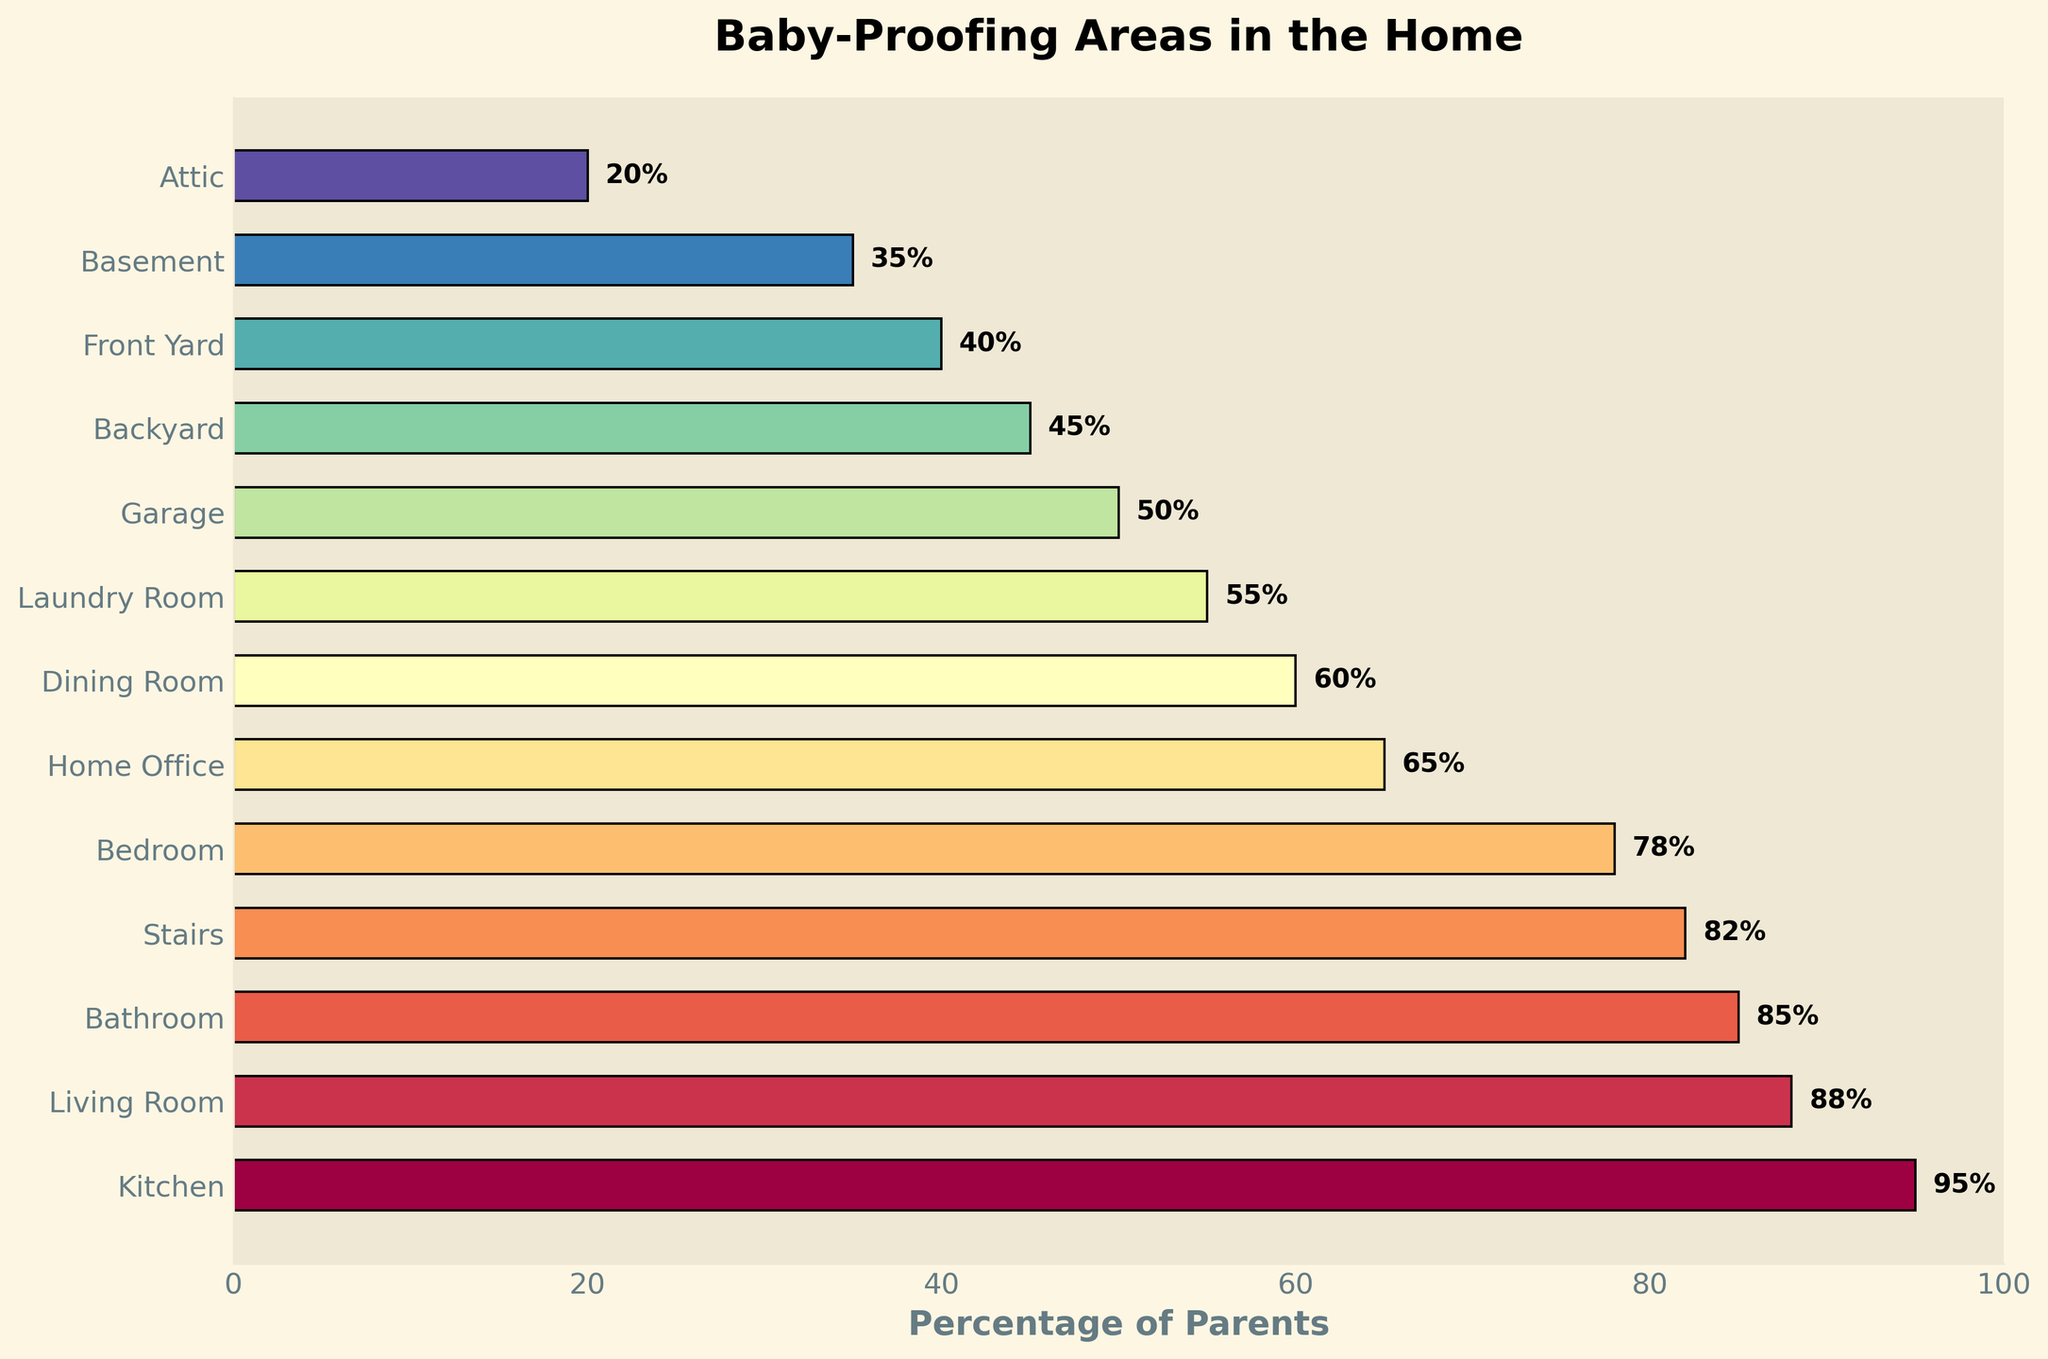Which area has the highest percentage of parents baby-proofing it? The bar chart shows that the kitchen has the highest percentage with a value of 95%.
Answer: Kitchen Which areas have a percentage above 80%? From the bar chart, the areas with percentages above 80% are the Kitchen (95%), Living Room (88%), Bathroom (85%), and Stairs (82%).
Answer: Kitchen, Living Room, Bathroom, Stairs What is the difference in baby-proofing percentage between the Kitchen and the Attic? The percentage for the Kitchen is 95%, and for the Attic, it is 20%. The difference is 95% - 20% = 75%.
Answer: 75% How many areas have percentages between 40% and 60%? From the chart, the areas with percentages between 40% and 60% are the Dining Room (60%) and the Laundry Room (55%). There are 2 such areas.
Answer: 2 Compare the baby-proofing percentages of the Bedroom and the Garage. Which one is higher, and by how much? The Bedroom has a baby-proofing percentage of 78%, and the Garage has 50%. The Bedroom is higher by 78% - 50% = 28%.
Answer: Bedroom is higher by 28% What is the average baby-proofing percentage of the top three areas? The top three areas are Kitchen (95%), Living Room (88%), and Bathroom (85%). Their average is (95 + 88 + 85) / 3 = 268 / 3 ≈ 89.33%.
Answer: ≈ 89.33% Do more parents baby-proof the Home Office or the Backyard? The chart shows that 65% of parents baby-proof the Home Office, while 45% baby-proof the Backyard. So, more parents baby-proof the Home Office.
Answer: Home Office Which areas have a lower percentage than the Garage? The areas with lower percentages than the Garage (50%) are the Backyard (45%), Front Yard (40%), Basement (35%), and Attic (20%).
Answer: Backyard, Front Yard, Basement, Attic What is the total percentage of parents baby-proofing the Dining Room and Laundry Room combined? The percentage for the Dining Room is 60% and for the Laundry Room, it is 55%. Combined, this total is 60% + 55% = 115%.
Answer: 115% Among the areas with percentages above 50%, which one has the lowest percentage? The areas above 50% are Kitchen, Living Room, Bathroom, Stairs, Bedroom, Home Office, Dining Room, and Laundry Room. Among these, the Laundry Room has the lowest percentage at 55%.
Answer: Laundry Room 